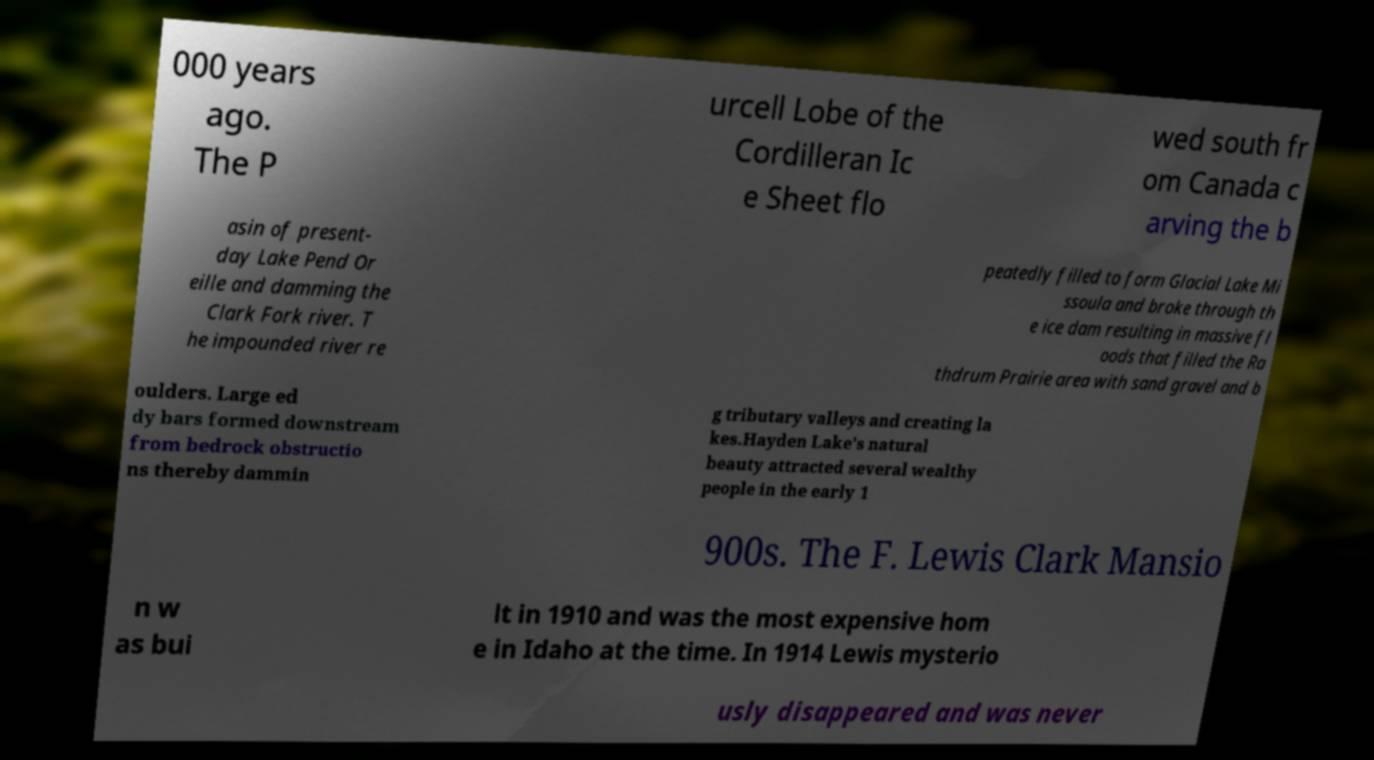For documentation purposes, I need the text within this image transcribed. Could you provide that? 000 years ago. The P urcell Lobe of the Cordilleran Ic e Sheet flo wed south fr om Canada c arving the b asin of present- day Lake Pend Or eille and damming the Clark Fork river. T he impounded river re peatedly filled to form Glacial Lake Mi ssoula and broke through th e ice dam resulting in massive fl oods that filled the Ra thdrum Prairie area with sand gravel and b oulders. Large ed dy bars formed downstream from bedrock obstructio ns thereby dammin g tributary valleys and creating la kes.Hayden Lake's natural beauty attracted several wealthy people in the early 1 900s. The F. Lewis Clark Mansio n w as bui lt in 1910 and was the most expensive hom e in Idaho at the time. In 1914 Lewis mysterio usly disappeared and was never 